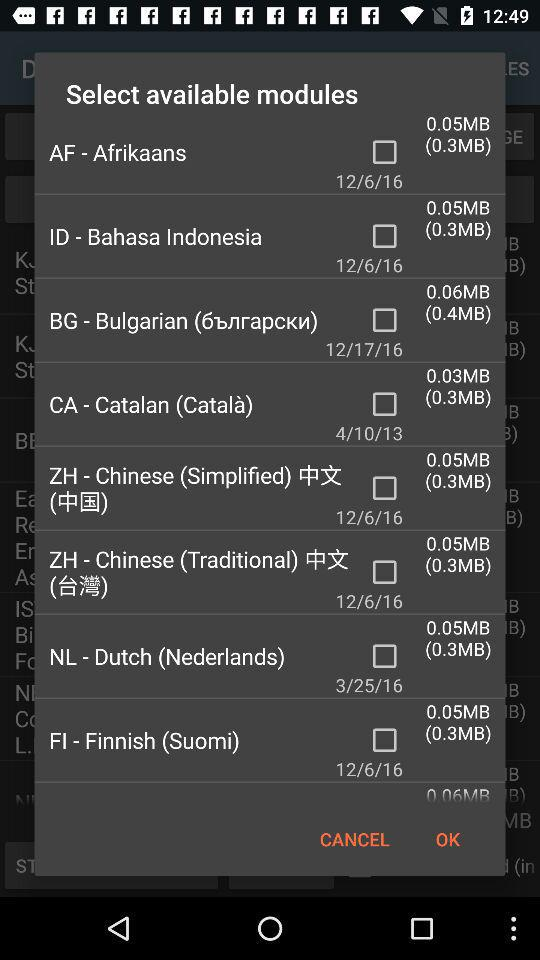What date is mentioned for "CA - Catalan (Català)"? The mentioned date is April 10, 2013. 